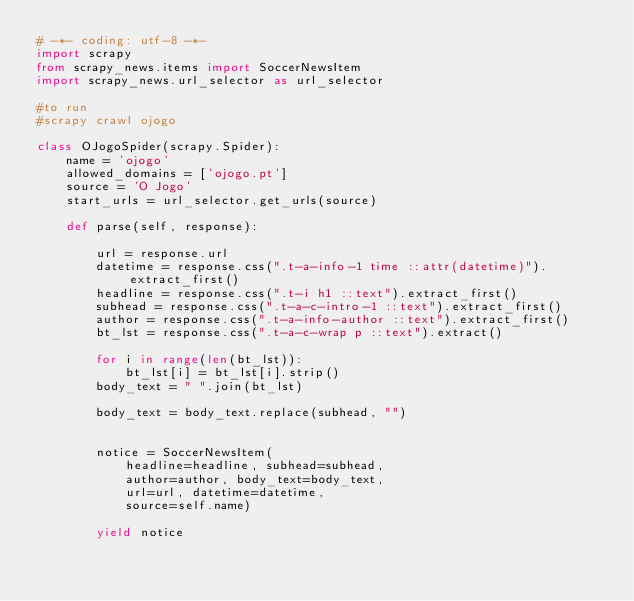<code> <loc_0><loc_0><loc_500><loc_500><_Python_># -*- coding: utf-8 -*-
import scrapy
from scrapy_news.items import SoccerNewsItem
import scrapy_news.url_selector as url_selector

#to run
#scrapy crawl ojogo

class OJogoSpider(scrapy.Spider):
    name = 'ojogo'
    allowed_domains = ['ojogo.pt']
    source = 'O Jogo'
    start_urls = url_selector.get_urls(source)

    def parse(self, response):

        url = response.url
        datetime = response.css(".t-a-info-1 time ::attr(datetime)").extract_first()
        headline = response.css(".t-i h1 ::text").extract_first()
        subhead = response.css(".t-a-c-intro-1 ::text").extract_first()
        author = response.css(".t-a-info-author ::text").extract_first()
        bt_lst = response.css(".t-a-c-wrap p ::text").extract()
 
        for i in range(len(bt_lst)):
            bt_lst[i] = bt_lst[i].strip()
        body_text = " ".join(bt_lst)

        body_text = body_text.replace(subhead, "")


        notice = SoccerNewsItem(
            headline=headline, subhead=subhead, 
            author=author, body_text=body_text, 
            url=url, datetime=datetime,
            source=self.name)

        yield notice



</code> 